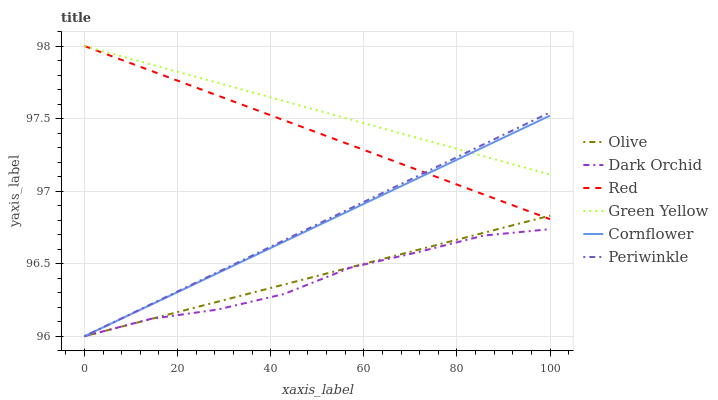Does Dark Orchid have the minimum area under the curve?
Answer yes or no. Yes. Does Green Yellow have the maximum area under the curve?
Answer yes or no. Yes. Does Periwinkle have the minimum area under the curve?
Answer yes or no. No. Does Periwinkle have the maximum area under the curve?
Answer yes or no. No. Is Cornflower the smoothest?
Answer yes or no. Yes. Is Dark Orchid the roughest?
Answer yes or no. Yes. Is Periwinkle the smoothest?
Answer yes or no. No. Is Periwinkle the roughest?
Answer yes or no. No. Does Cornflower have the lowest value?
Answer yes or no. Yes. Does Green Yellow have the lowest value?
Answer yes or no. No. Does Red have the highest value?
Answer yes or no. Yes. Does Periwinkle have the highest value?
Answer yes or no. No. Is Dark Orchid less than Red?
Answer yes or no. Yes. Is Red greater than Dark Orchid?
Answer yes or no. Yes. Does Olive intersect Dark Orchid?
Answer yes or no. Yes. Is Olive less than Dark Orchid?
Answer yes or no. No. Is Olive greater than Dark Orchid?
Answer yes or no. No. Does Dark Orchid intersect Red?
Answer yes or no. No. 